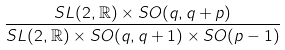Convert formula to latex. <formula><loc_0><loc_0><loc_500><loc_500>\frac { S L ( 2 , \mathbb { R } ) \times S O ( q , q + p ) } { S L ( 2 , \mathbb { R } ) \times S O ( q , q + 1 ) \times S O ( p - 1 ) }</formula> 